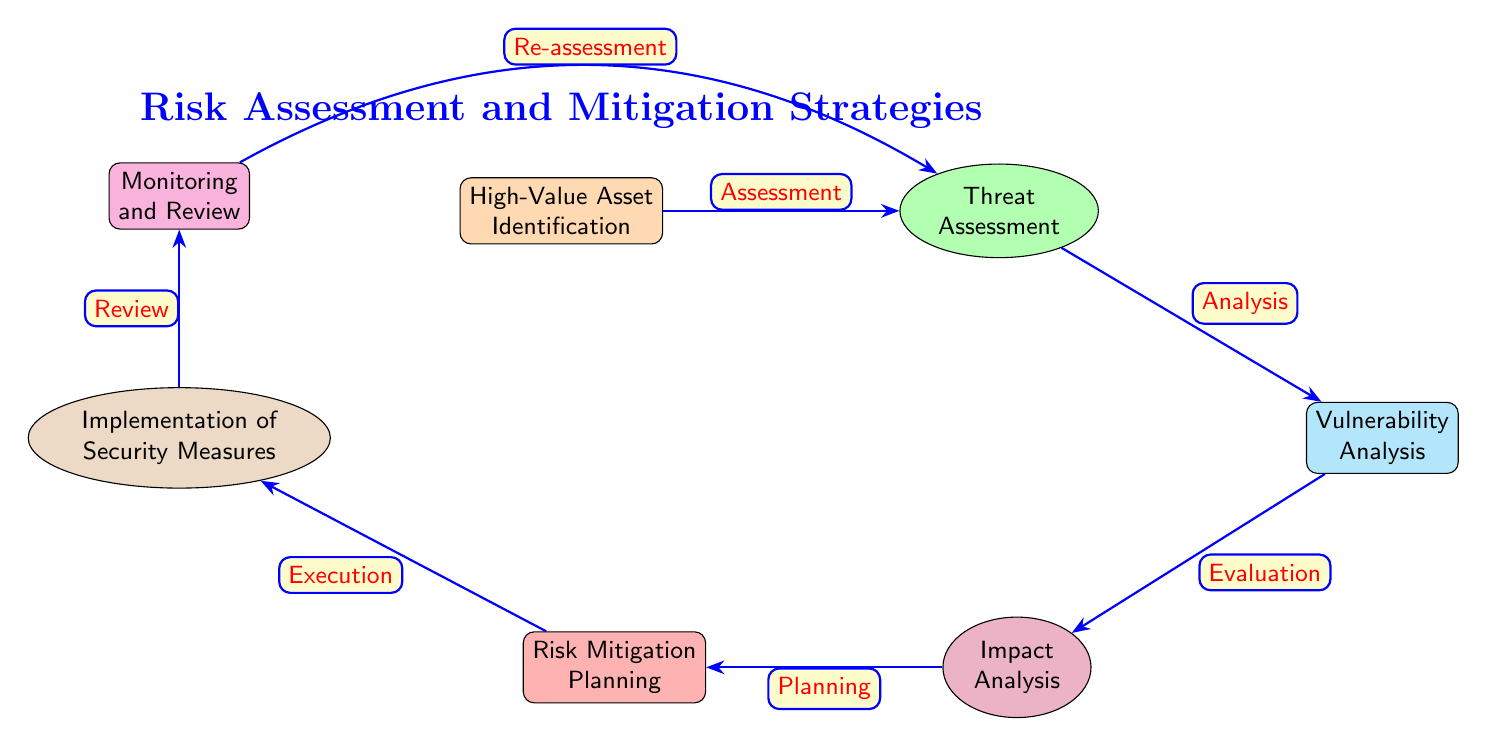What is the first step in the risk assessment process? The diagram indicates that the first step in the process is labeled as "High-Value Asset Identification." This node is positioned at the top and is the initial part of the flowchart.
Answer: High-Value Asset Identification How many nodes are in the diagram? By counting all the unique elements depicted in the diagram, a total of 7 distinct nodes can be identified: one for each step in the process.
Answer: 7 What follows after "Threat Assessment"? The flow diagram shows that "Threat Assessment" is directly followed by "Vulnerability Analysis," which is the next step in the process.
Answer: Vulnerability Analysis What type of node is "Impact Analysis"? The diagram designates "Impact Analysis" as an ellipse node, which is a specific shape used to indicate different types of elements in the flowchart.
Answer: Ellipse What action is taken after "Risk Mitigation Planning"? According to the diagram, after the "Risk Mitigation Planning" step, the process moves on to "Implementation of Security Measures," indicating a sequential action that follows the planning stage.
Answer: Implementation of Security Measures Which node connects back to "Threat Assessment"? The diagram depicts that "Monitoring and Review" has an arrow indicating "Re-assessment" that loops back to "Threat Assessment," creating a feedback mechanism in the process.
Answer: Re-assessment What color represents "Implementation of Security Measures"? In the diagram, "Implementation of Security Measures" is filled with a brown color, which distinguishes it visually from other nodes.
Answer: Brown What is the overall title of the diagram? The title of the diagram is placed above the first node and clearly states "Risk Assessment and Mitigation Strategies," summarizing the content that follows in the flowchart.
Answer: Risk Assessment and Mitigation Strategies 